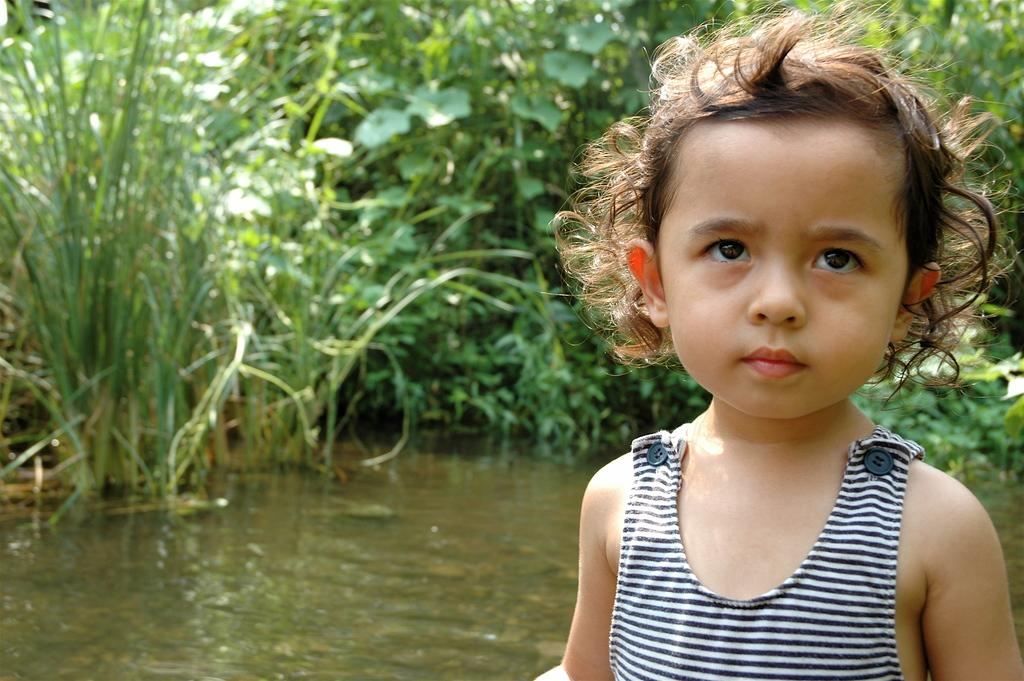Who or what is the main subject in the image? There is a child in the image. What can be seen in the background of the image? Water and plants are visible in the background of the image. What type of vein is visible in the image? There is no vein visible in the image. How does the child express love in the image? The image does not show the child expressing love, as it only depicts the child and the background. 